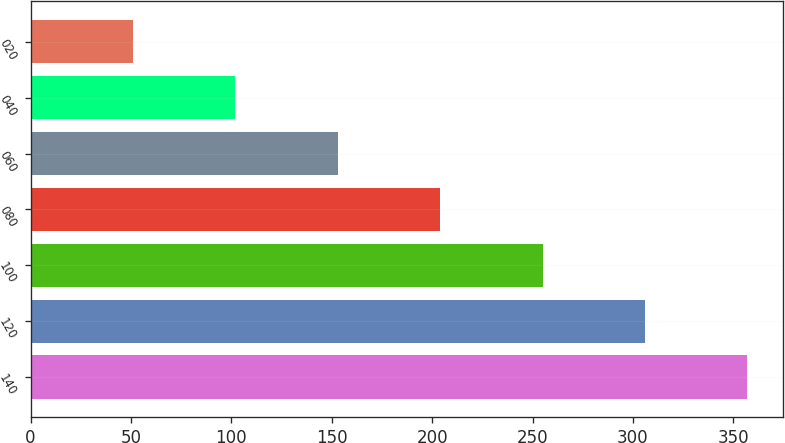Convert chart. <chart><loc_0><loc_0><loc_500><loc_500><bar_chart><fcel>140<fcel>120<fcel>100<fcel>080<fcel>060<fcel>040<fcel>020<nl><fcel>357<fcel>306<fcel>255<fcel>204<fcel>153<fcel>102<fcel>51<nl></chart> 